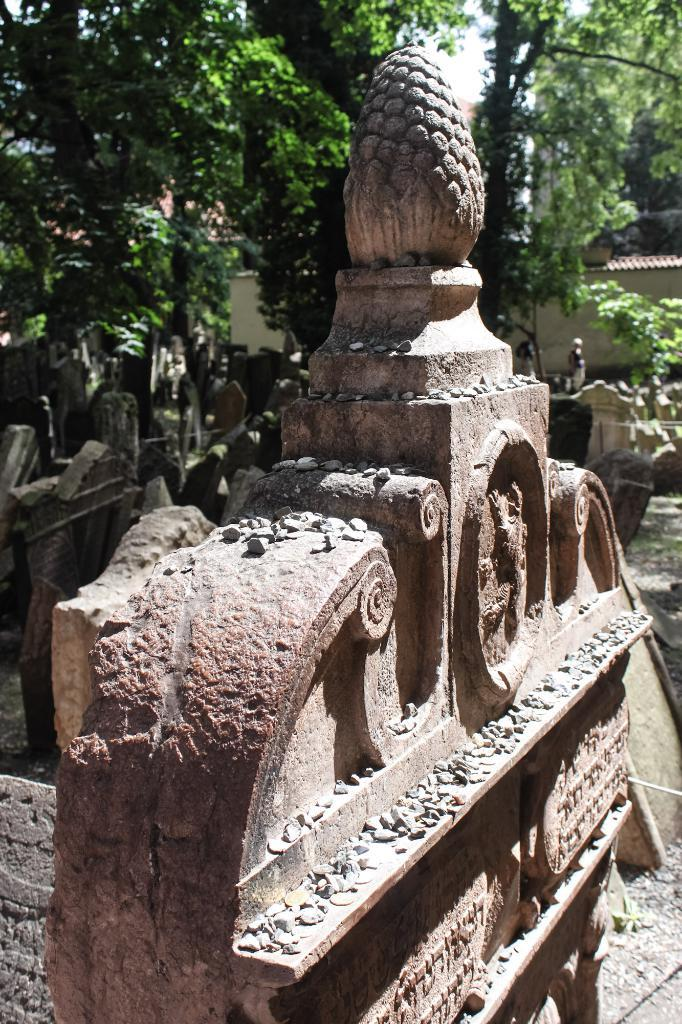What is the main subject of the image? There is a sculptured stone in the image. What can be observed on the stone? The stone has designs on it. What type of vegetation is visible in the image? There are plants visible in the image. What can be seen in the background of the image? There is a wall and trees present in the background of the image. What type of birds can be seen flying near the sculptured stone in the image? There are no birds visible in the image; it only features a sculptured stone, plants, and a background with a wall and trees. 